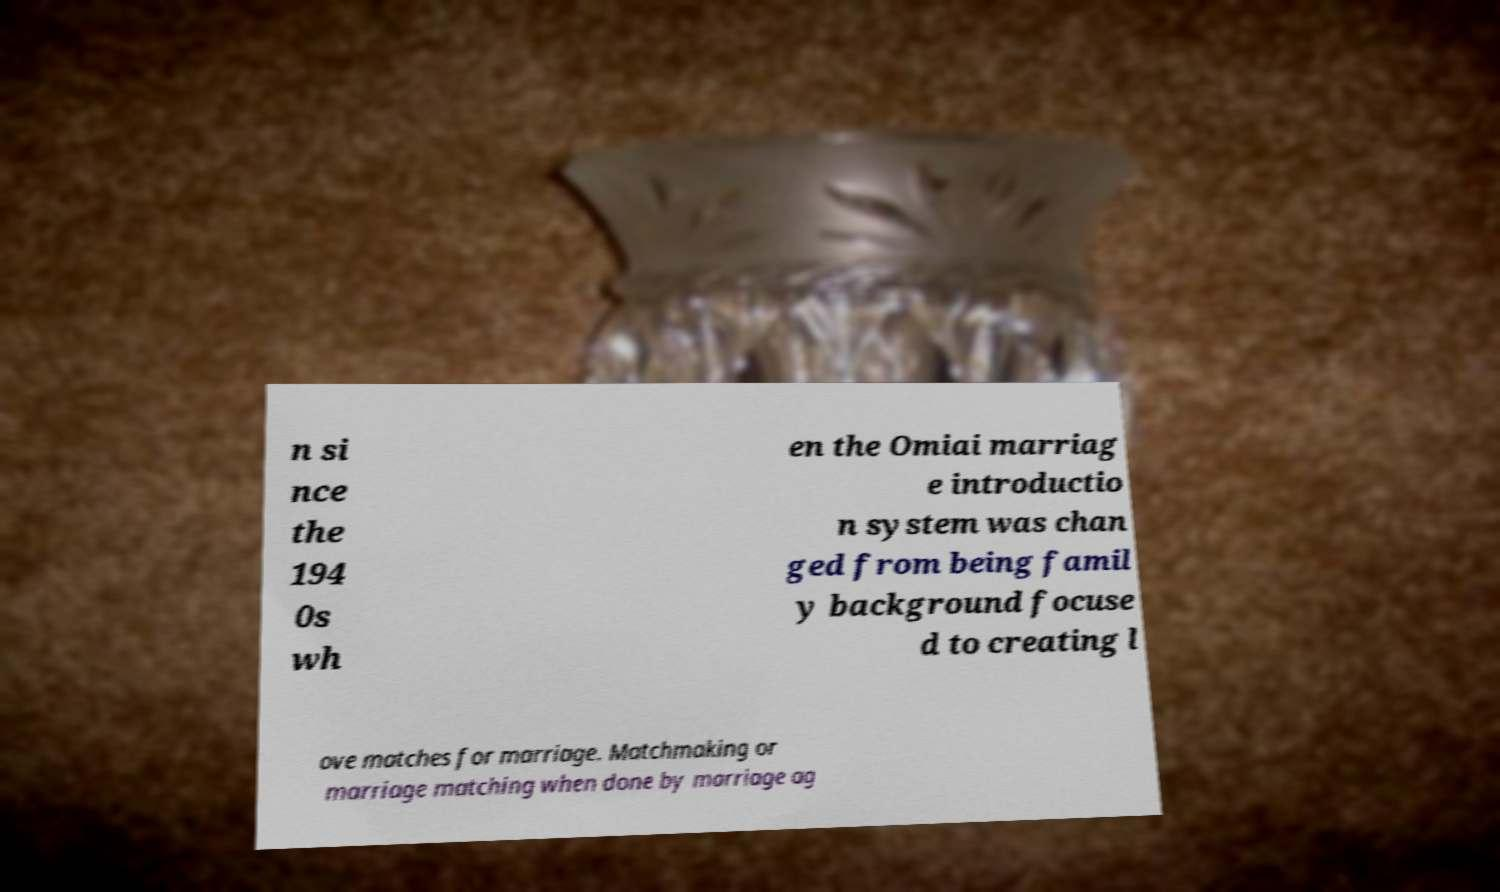Could you extract and type out the text from this image? n si nce the 194 0s wh en the Omiai marriag e introductio n system was chan ged from being famil y background focuse d to creating l ove matches for marriage. Matchmaking or marriage matching when done by marriage ag 